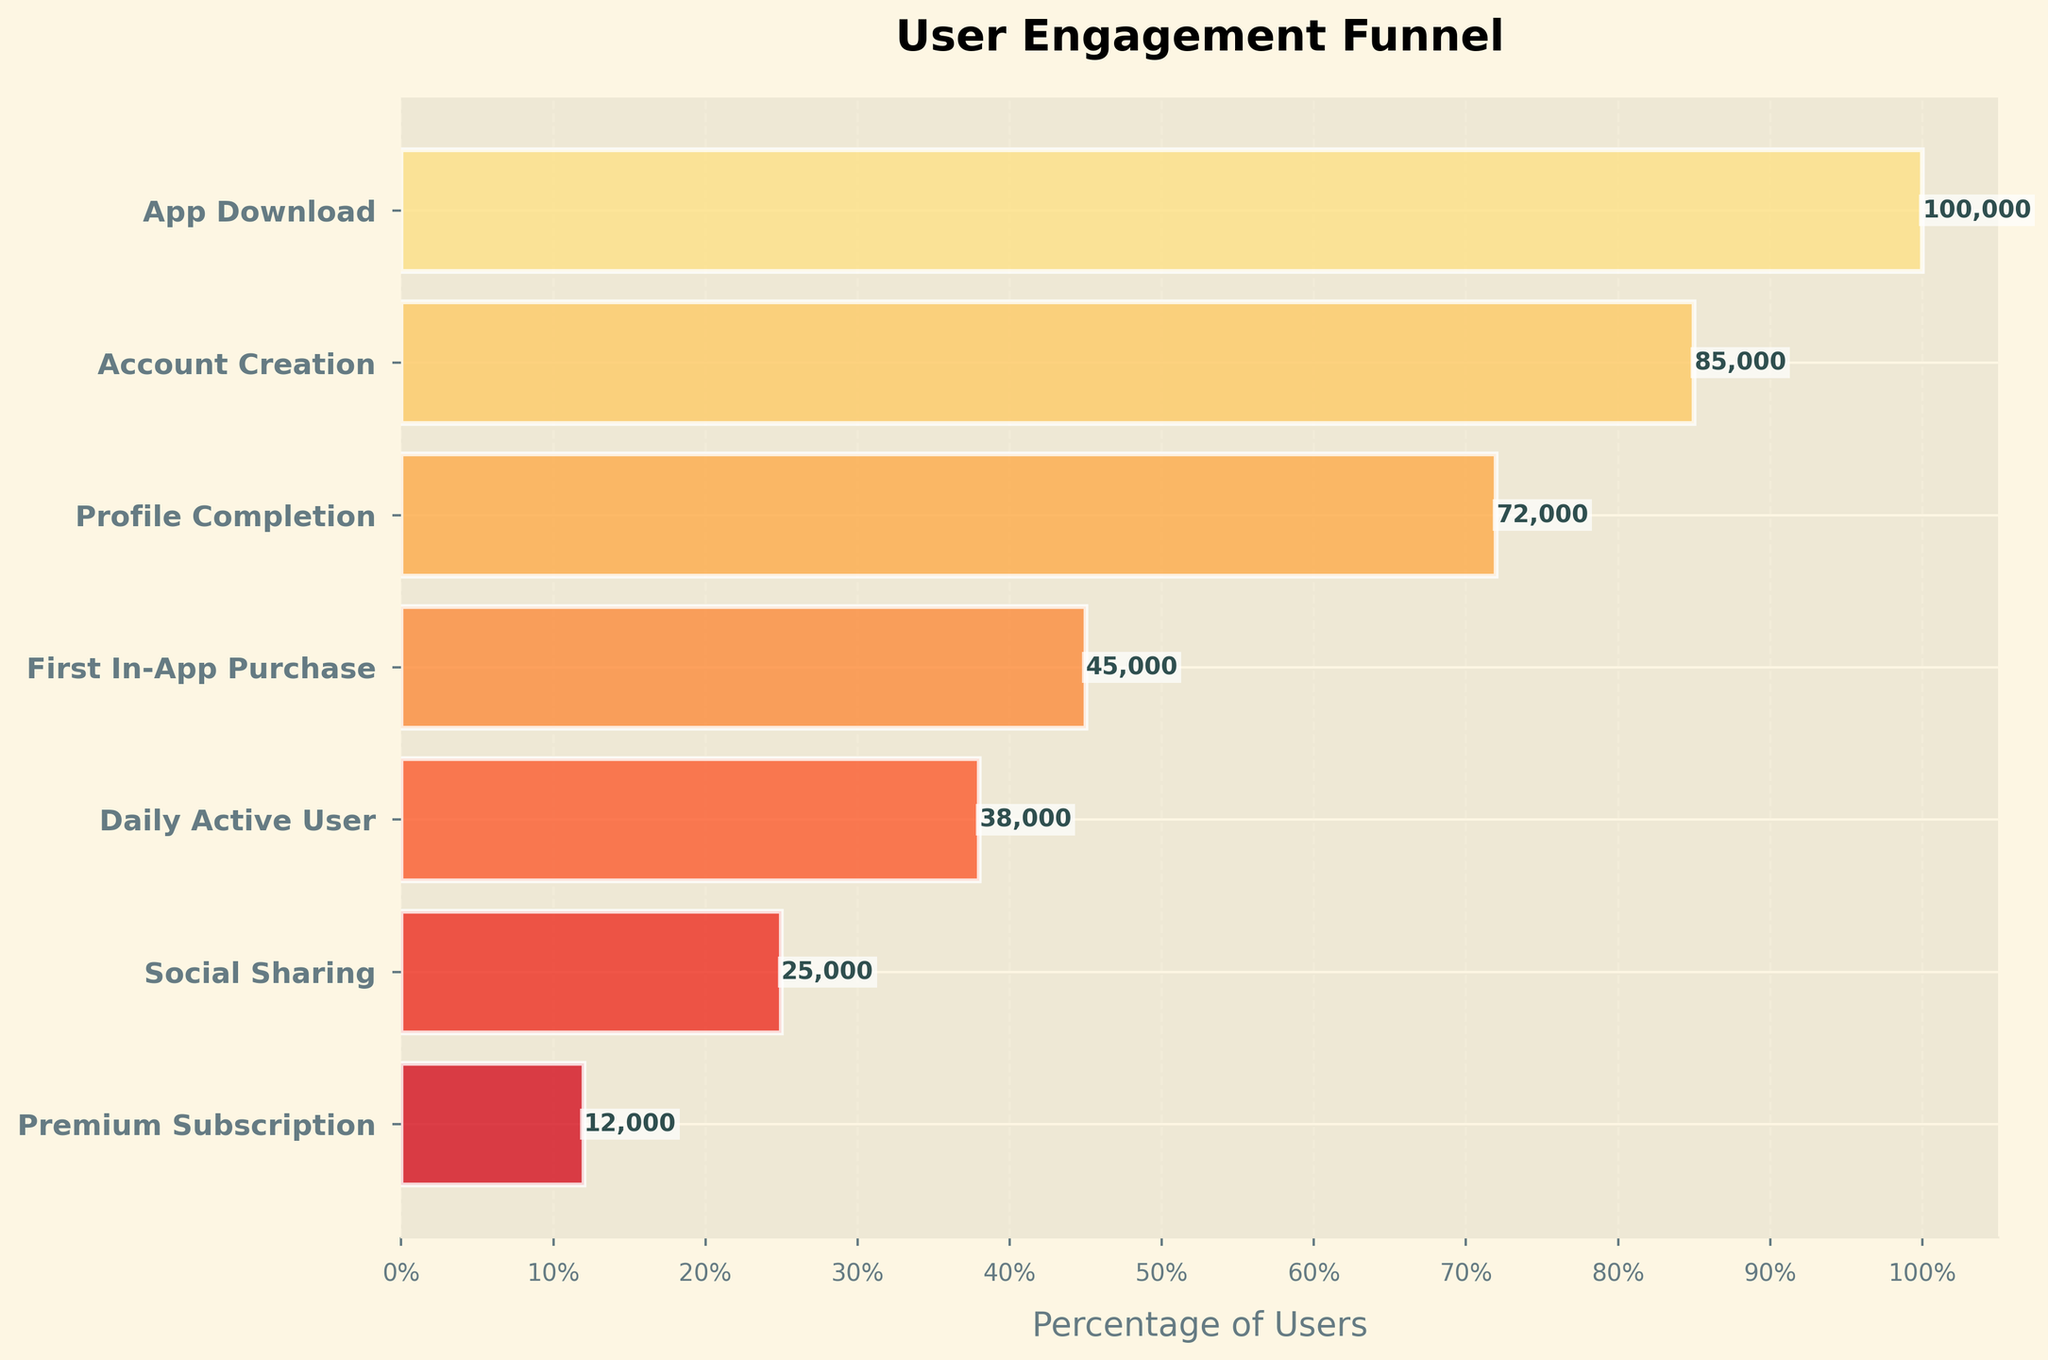What is the title of the chart? The title is typically displayed at the top of the chart and is used to give a brief description of what the chart represents. The title of this chart is "User Engagement Funnel".
Answer: User Engagement Funnel How many stages are displayed in the funnel? Count the number of different stages along the y-axis of the funnel chart. There are 7 stages indicated by different labels on the y-axis.
Answer: 7 Which stage has the highest number of users? Look for the stage with the widest bar at the top. The widest bar represents the number of users who have downloaded the app.
Answer: App Download What is the number of users who completed their profile? Identify the bar labeled "Profile Completion" and check the number provided near that bar, which represents the number of users who completed their profile.
Answer: 72,000 How many users made a first in-app purchase? Locate the bar labeled "First In-App Purchase" and refer to the text near the bar, which shows the number of users who made their first purchase within the app.
Answer: 45,000 Calculate the drop in users from "Account Creation" to "Profile Completion". Subtract the number of users who completed their profile from the number of users who created an account: 85,000 (Account Creation) - 72,000 (Profile Completion).
Answer: 13,000 What percentage of users who created an account also completed their profile? Divide the number of users who completed their profile by the number of users who created an account and multiply by 100. \( \frac{72,000}{85,000} \times 100 \approx 84.71\% \)
Answer: 84.71% Compare the number of daily active users to the number of users who made a first in-app purchase. Which is greater? Compare the numbers provided near the bars for "Daily Active User" and "First In-App Purchase". "First In-App Purchase" has 45,000 users, and "Daily Active User" has 38,000 users. 45,000 is greater than 38,000.
Answer: First In-App Purchase Which stage has the least number of users? Look for the narrowest bar at the bottom of the chart. The stage with the least number of users is labeled "Premium Subscription".
Answer: Premium Subscription How does the number of users who socially shared compare to those with a Premium Subscription? Compare the numbers near the bars for "Social Sharing" and "Premium Subscription". Social Sharing has 25,000 users and Premium Subscription has 12,000 users. 25,000 is greater than 12,000.
Answer: Social Sharing 